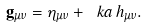<formula> <loc_0><loc_0><loc_500><loc_500>\mathbf g _ { \mu \nu } = \eta _ { \mu \nu } + \ k a \, h _ { \mu \nu } .</formula> 